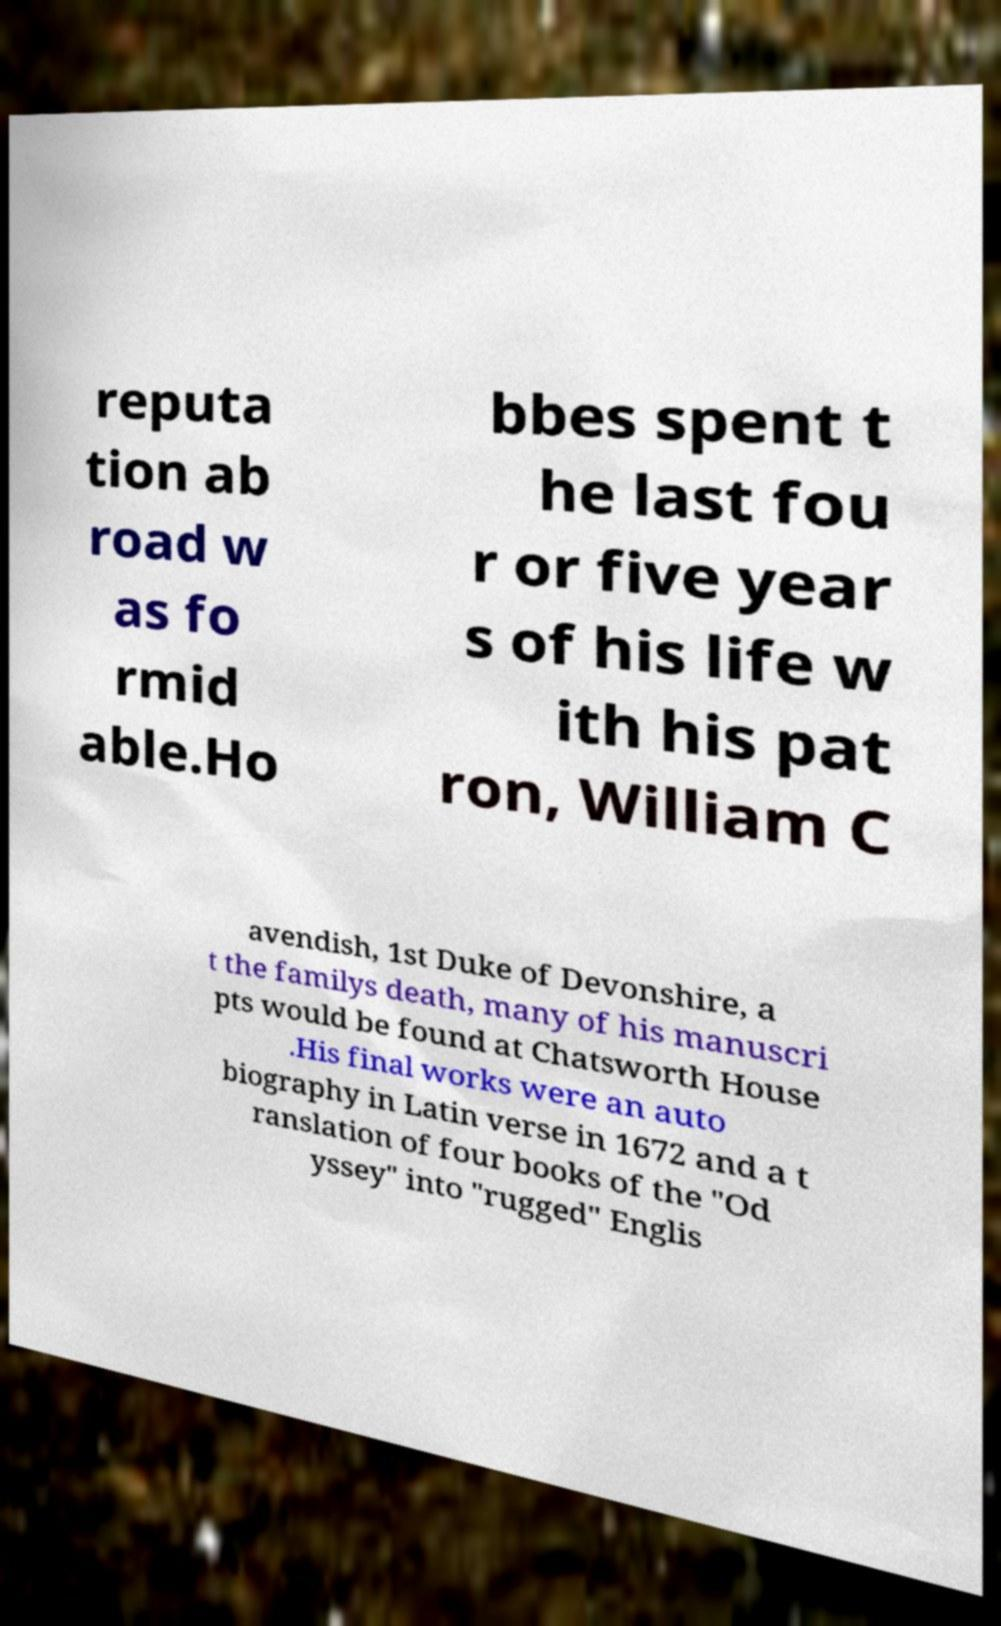Please identify and transcribe the text found in this image. reputa tion ab road w as fo rmid able.Ho bbes spent t he last fou r or five year s of his life w ith his pat ron, William C avendish, 1st Duke of Devonshire, a t the familys death, many of his manuscri pts would be found at Chatsworth House .His final works were an auto biography in Latin verse in 1672 and a t ranslation of four books of the "Od yssey" into "rugged" Englis 